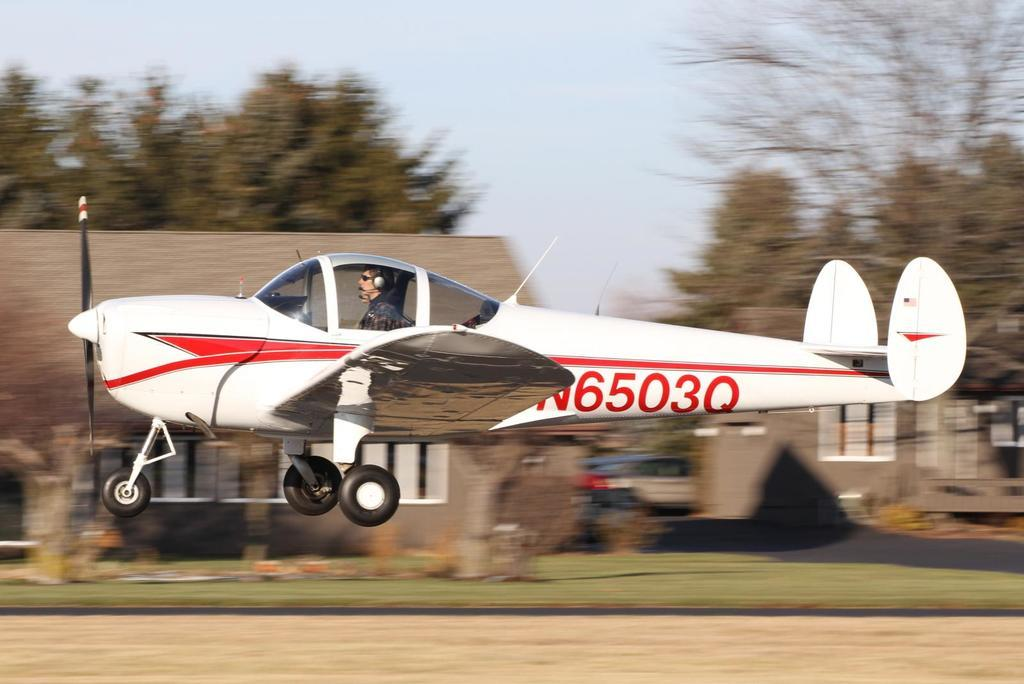What can be seen in the image? There is a person in the image. What is the person wearing? The person is wearing headphones. Where is the person located? The person is sitting inside an airplane. What can be seen in the background of the image? There are buildings, vehicles, trees, and the sky visible in the background of the image. What is the voice of the person in the image? There is no information about the person's voice in the image. Can you see a spot on the person's clothing in the image? There is no mention of a spot on the person's clothing in the image. 